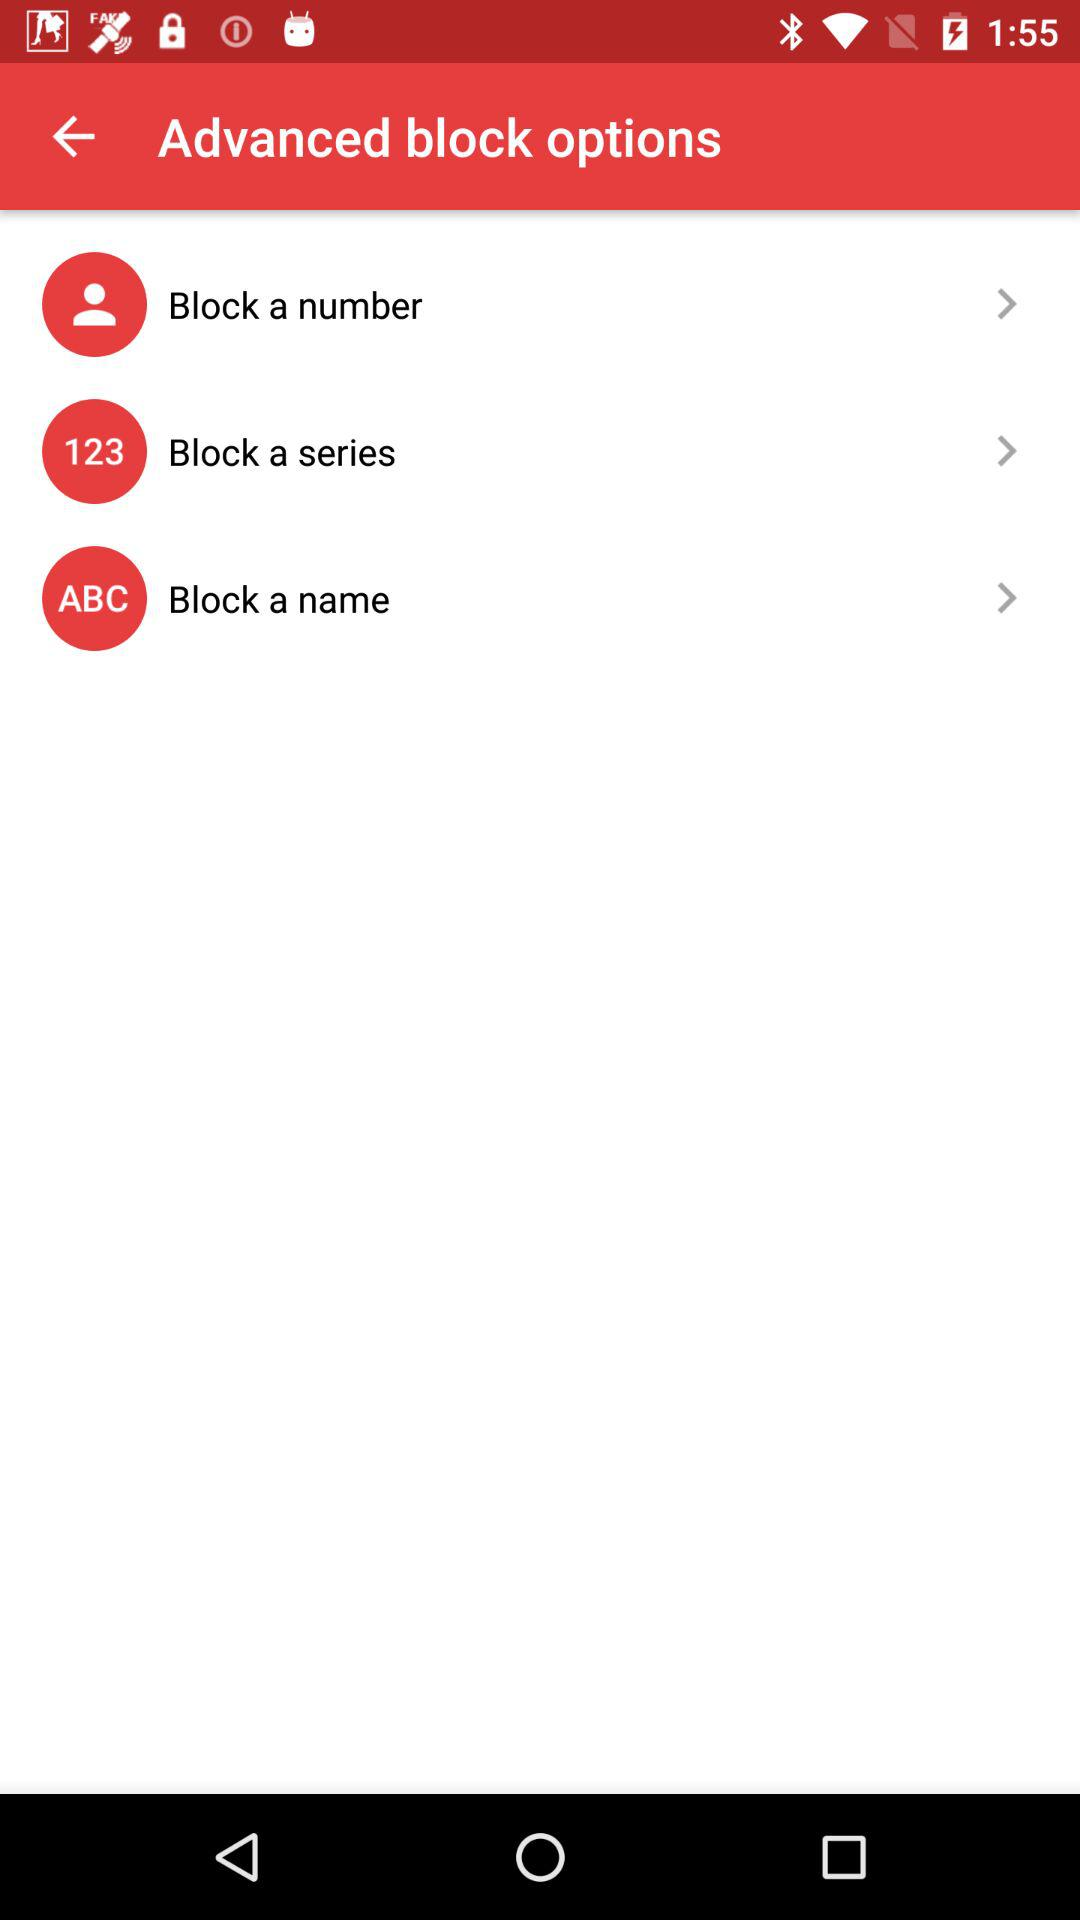What are the different options to block? The different options are "Block a number", "Block a series" and "Block a name". 